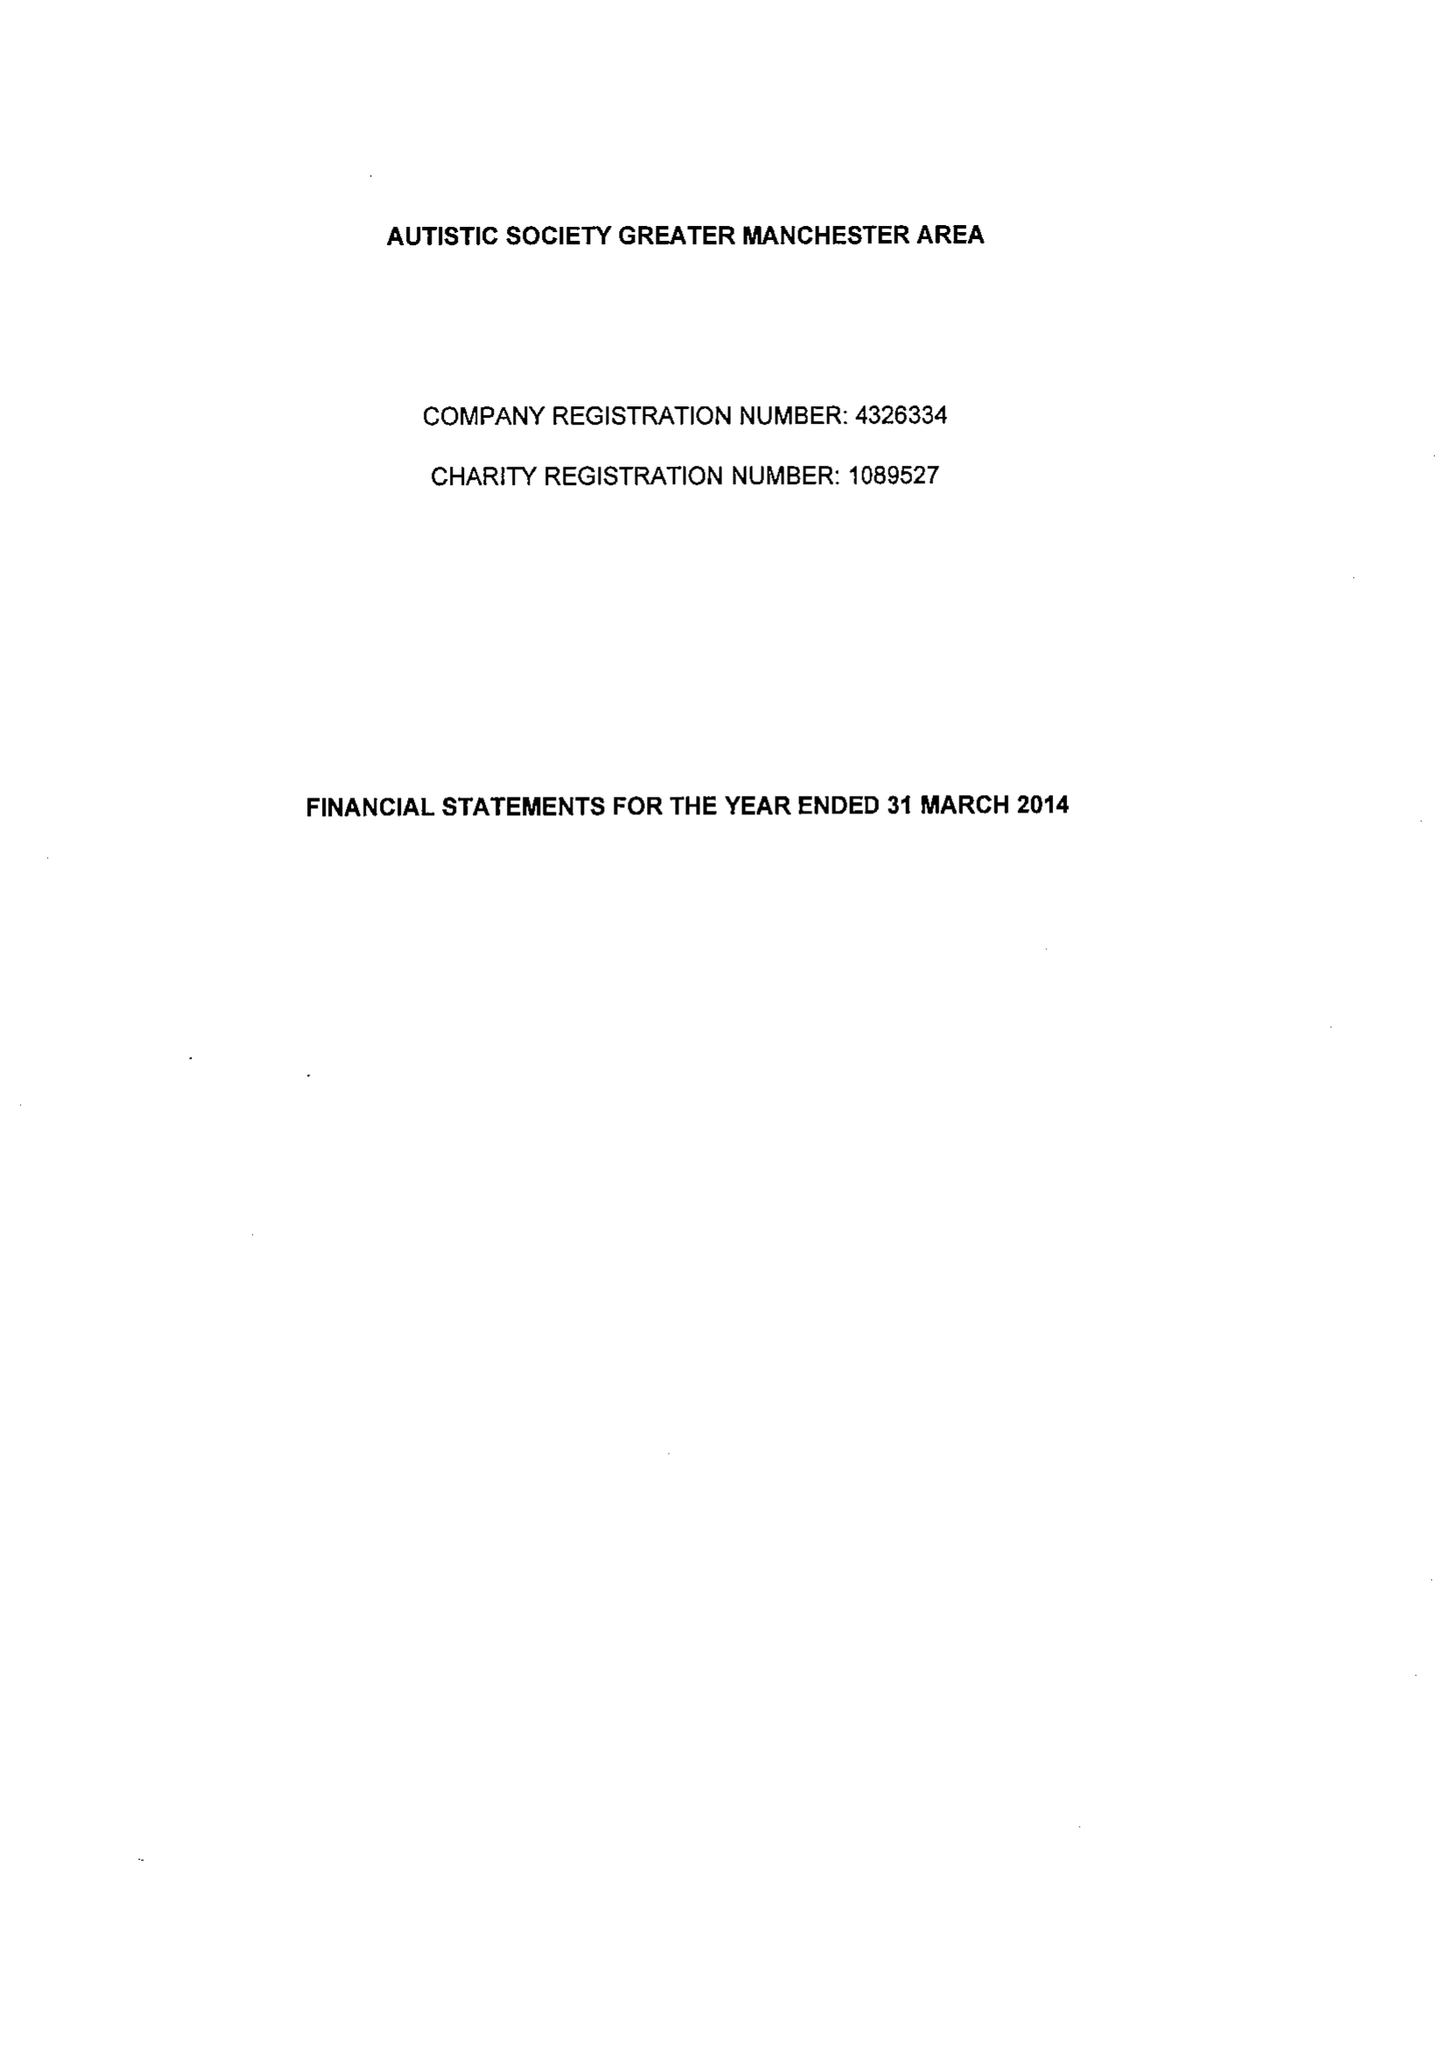What is the value for the income_annually_in_british_pounds?
Answer the question using a single word or phrase. 318138.00 